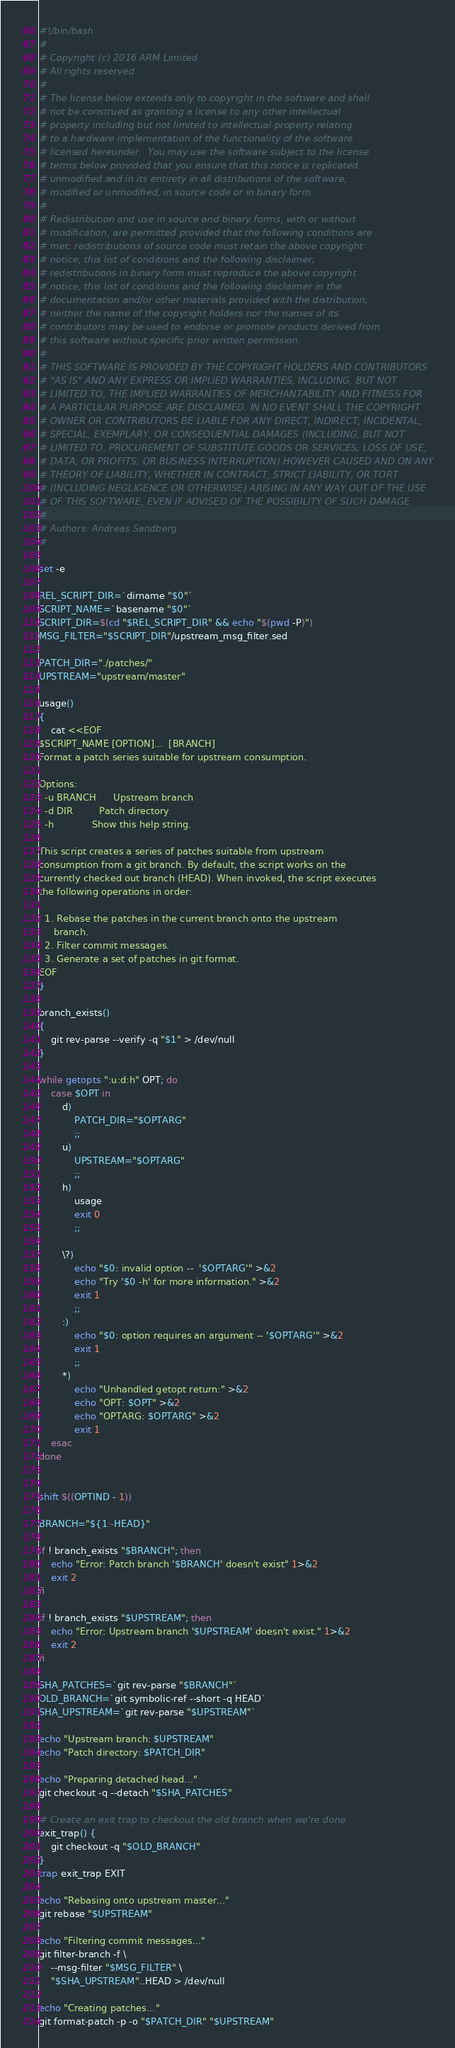Convert code to text. <code><loc_0><loc_0><loc_500><loc_500><_Bash_>#!/bin/bash
#
# Copyright (c) 2016 ARM Limited
# All rights reserved
#
# The license below extends only to copyright in the software and shall
# not be construed as granting a license to any other intellectual
# property including but not limited to intellectual property relating
# to a hardware implementation of the functionality of the software
# licensed hereunder.  You may use the software subject to the license
# terms below provided that you ensure that this notice is replicated
# unmodified and in its entirety in all distributions of the software,
# modified or unmodified, in source code or in binary form.
#
# Redistribution and use in source and binary forms, with or without
# modification, are permitted provided that the following conditions are
# met: redistributions of source code must retain the above copyright
# notice, this list of conditions and the following disclaimer;
# redistributions in binary form must reproduce the above copyright
# notice, this list of conditions and the following disclaimer in the
# documentation and/or other materials provided with the distribution;
# neither the name of the copyright holders nor the names of its
# contributors may be used to endorse or promote products derived from
# this software without specific prior written permission.
#
# THIS SOFTWARE IS PROVIDED BY THE COPYRIGHT HOLDERS AND CONTRIBUTORS
# "AS IS" AND ANY EXPRESS OR IMPLIED WARRANTIES, INCLUDING, BUT NOT
# LIMITED TO, THE IMPLIED WARRANTIES OF MERCHANTABILITY AND FITNESS FOR
# A PARTICULAR PURPOSE ARE DISCLAIMED. IN NO EVENT SHALL THE COPYRIGHT
# OWNER OR CONTRIBUTORS BE LIABLE FOR ANY DIRECT, INDIRECT, INCIDENTAL,
# SPECIAL, EXEMPLARY, OR CONSEQUENTIAL DAMAGES (INCLUDING, BUT NOT
# LIMITED TO, PROCUREMENT OF SUBSTITUTE GOODS OR SERVICES; LOSS OF USE,
# DATA, OR PROFITS; OR BUSINESS INTERRUPTION) HOWEVER CAUSED AND ON ANY
# THEORY OF LIABILITY, WHETHER IN CONTRACT, STRICT LIABILITY, OR TORT
# (INCLUDING NEGLIGENCE OR OTHERWISE) ARISING IN ANY WAY OUT OF THE USE
# OF THIS SOFTWARE, EVEN IF ADVISED OF THE POSSIBILITY OF SUCH DAMAGE.
#
# Authors: Andreas Sandberg
#

set -e

REL_SCRIPT_DIR=`dirname "$0"`
SCRIPT_NAME=`basename "$0"`
SCRIPT_DIR=$(cd "$REL_SCRIPT_DIR" && echo "$(pwd -P)")
MSG_FILTER="$SCRIPT_DIR"/upstream_msg_filter.sed

PATCH_DIR="./patches/"
UPSTREAM="upstream/master"

usage()
{
    cat <<EOF
$SCRIPT_NAME [OPTION]...  [BRANCH]
Format a patch series suitable for upstream consumption.

Options:
  -u BRANCH      Upstream branch
  -d DIR         Patch directory
  -h             Show this help string.

This script creates a series of patches suitable from upstream
consumption from a git branch. By default, the script works on the
currently checked out branch (HEAD). When invoked, the script executes
the following operations in order:

  1. Rebase the patches in the current branch onto the upstream
     branch.
  2. Filter commit messages.
  3. Generate a set of patches in git format.
EOF
}

branch_exists()
{
    git rev-parse --verify -q "$1" > /dev/null
}

while getopts ":u:d:h" OPT; do
    case $OPT in
        d)
            PATCH_DIR="$OPTARG"
            ;;
        u)
            UPSTREAM="$OPTARG"
            ;;
        h)
            usage
            exit 0
            ;;

        \?)
            echo "$0: invalid option --  '$OPTARG'" >&2
            echo "Try '$0 -h' for more information." >&2
            exit 1
            ;;
        :)
            echo "$0: option requires an argument -- '$OPTARG'" >&2
            exit 1
            ;;
        *)
            echo "Unhandled getopt return:" >&2
            echo "OPT: $OPT" >&2
            echo "OPTARG: $OPTARG" >&2
            exit 1
    esac
done


shift $((OPTIND - 1))

BRANCH="${1:-HEAD}"

if ! branch_exists "$BRANCH"; then
    echo "Error: Patch branch '$BRANCH' doesn't exist" 1>&2
    exit 2
fi

if ! branch_exists "$UPSTREAM"; then
    echo "Error: Upstream branch '$UPSTREAM' doesn't exist." 1>&2
    exit 2
fi

SHA_PATCHES=`git rev-parse "$BRANCH"`
OLD_BRANCH=`git symbolic-ref --short -q HEAD`
SHA_UPSTREAM=`git rev-parse "$UPSTREAM"`

echo "Upstream branch: $UPSTREAM"
echo "Patch directory: $PATCH_DIR"

echo "Preparing detached head..."
git checkout -q --detach "$SHA_PATCHES"

# Create an exit trap to checkout the old branch when we're done
exit_trap() {
    git checkout -q "$OLD_BRANCH"
}
trap exit_trap EXIT

echo "Rebasing onto upstream master..."
git rebase "$UPSTREAM"

echo "Filtering commit messages..."
git filter-branch -f \
    --msg-filter "$MSG_FILTER" \
    "$SHA_UPSTREAM"..HEAD > /dev/null

echo "Creating patches..."
git format-patch -p -o "$PATCH_DIR" "$UPSTREAM"
</code> 